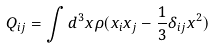<formula> <loc_0><loc_0><loc_500><loc_500>Q _ { i j } = \int d ^ { 3 } x \rho ( x _ { i } x _ { j } - \frac { 1 } { 3 } \delta _ { i j } { x } ^ { 2 } )</formula> 